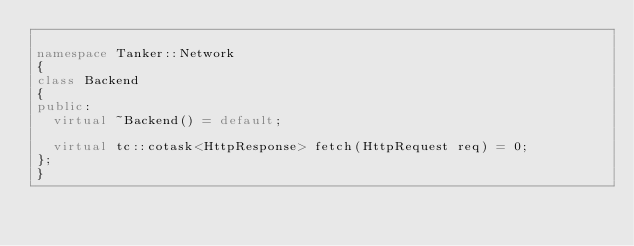<code> <loc_0><loc_0><loc_500><loc_500><_C++_>
namespace Tanker::Network
{
class Backend
{
public:
  virtual ~Backend() = default;

  virtual tc::cotask<HttpResponse> fetch(HttpRequest req) = 0;
};
}
</code> 